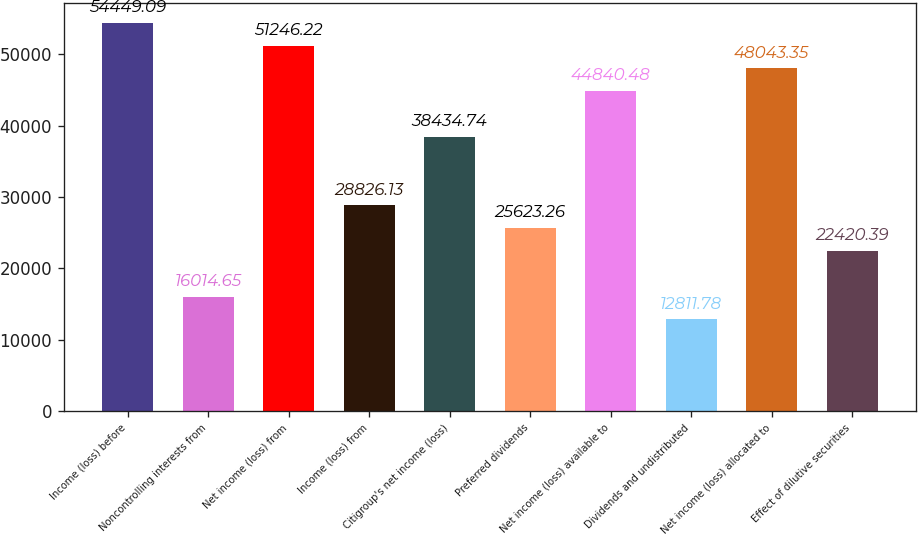<chart> <loc_0><loc_0><loc_500><loc_500><bar_chart><fcel>Income (loss) before<fcel>Noncontrolling interests from<fcel>Net income (loss) from<fcel>Income (loss) from<fcel>Citigroup's net income (loss)<fcel>Preferred dividends<fcel>Net income (loss) available to<fcel>Dividends and undistributed<fcel>Net income (loss) allocated to<fcel>Effect of dilutive securities<nl><fcel>54449.1<fcel>16014.6<fcel>51246.2<fcel>28826.1<fcel>38434.7<fcel>25623.3<fcel>44840.5<fcel>12811.8<fcel>48043.3<fcel>22420.4<nl></chart> 